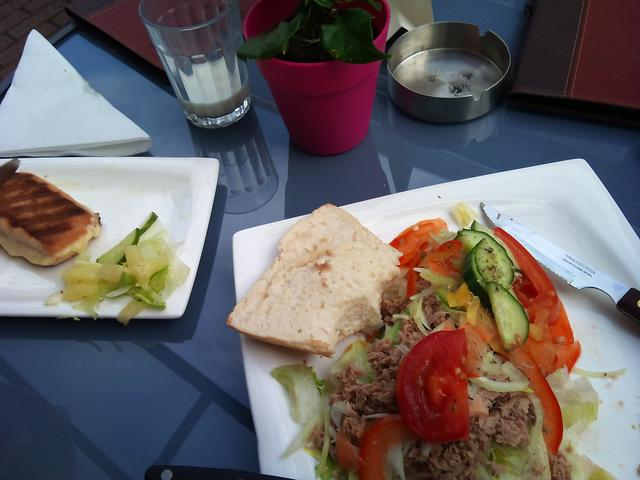What do the stains on the middle top metal thing come from?

Choices:
A) blood
B) juice
C) oil
D) cigarettes cigarettes 